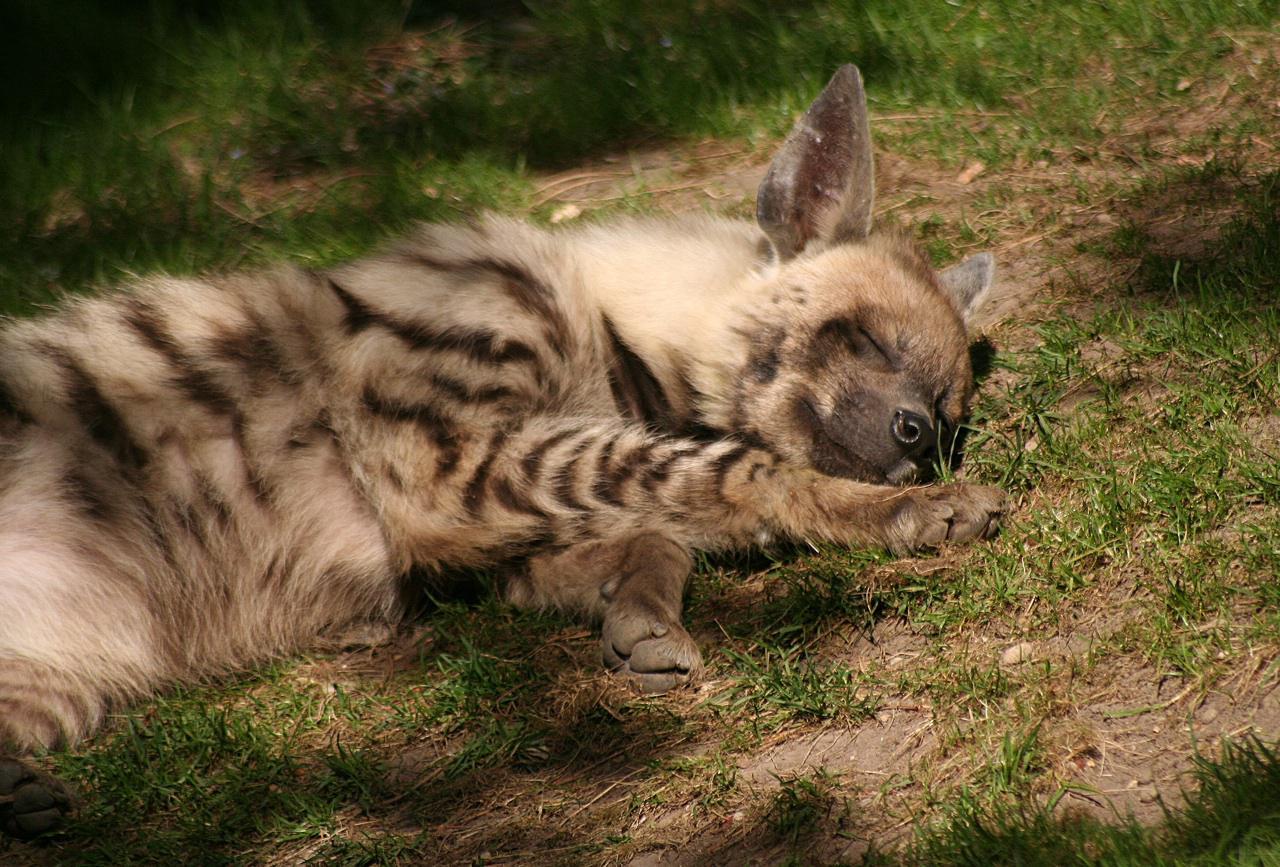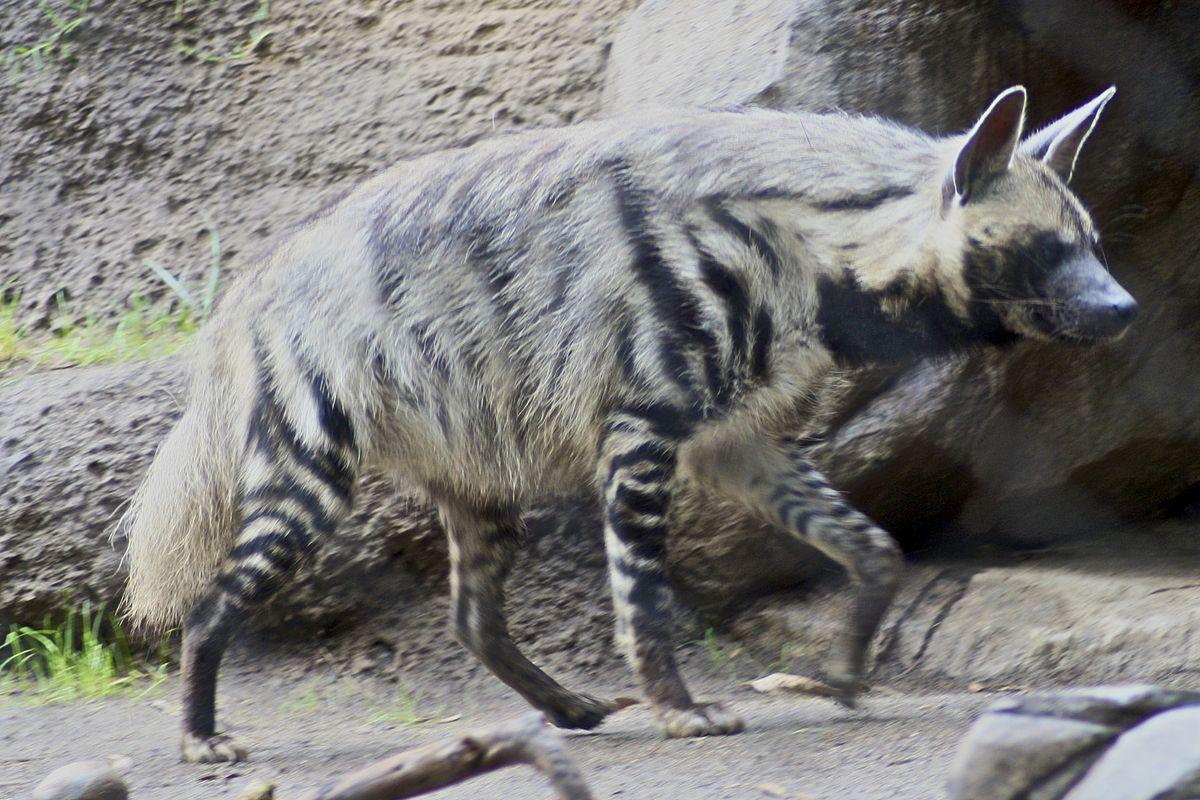The first image is the image on the left, the second image is the image on the right. Analyze the images presented: Is the assertion "There are exactly two sleeping hyenas." valid? Answer yes or no. No. The first image is the image on the left, the second image is the image on the right. Given the left and right images, does the statement "At least one animal is resting underneath of a rocky covering." hold true? Answer yes or no. No. 